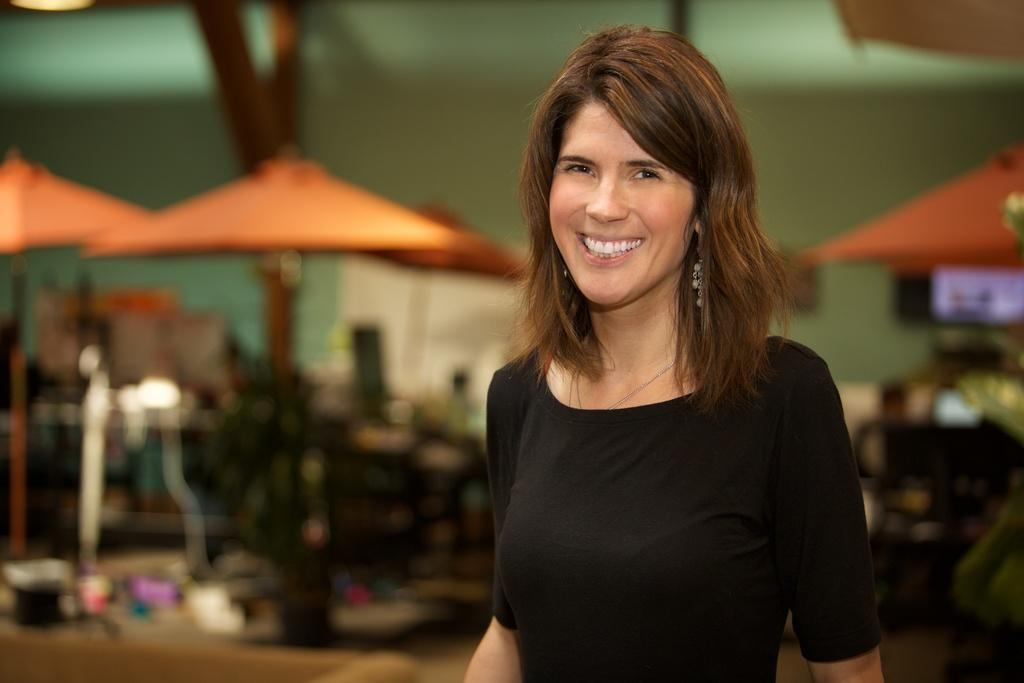What can be observed about the background of the image? The background portion of the picture is blurred. What else can be seen in the image besides the background? There are objects visible in the image. Can you describe the woman in the image? There is a woman in the image, and she is wearing a black dress. What expression does the woman have in the image? The woman is smiling in the image. How many pizzas are being delivered in the image? There are no pizzas or delivery in the image; it features a woman wearing a black dress and smiling. 